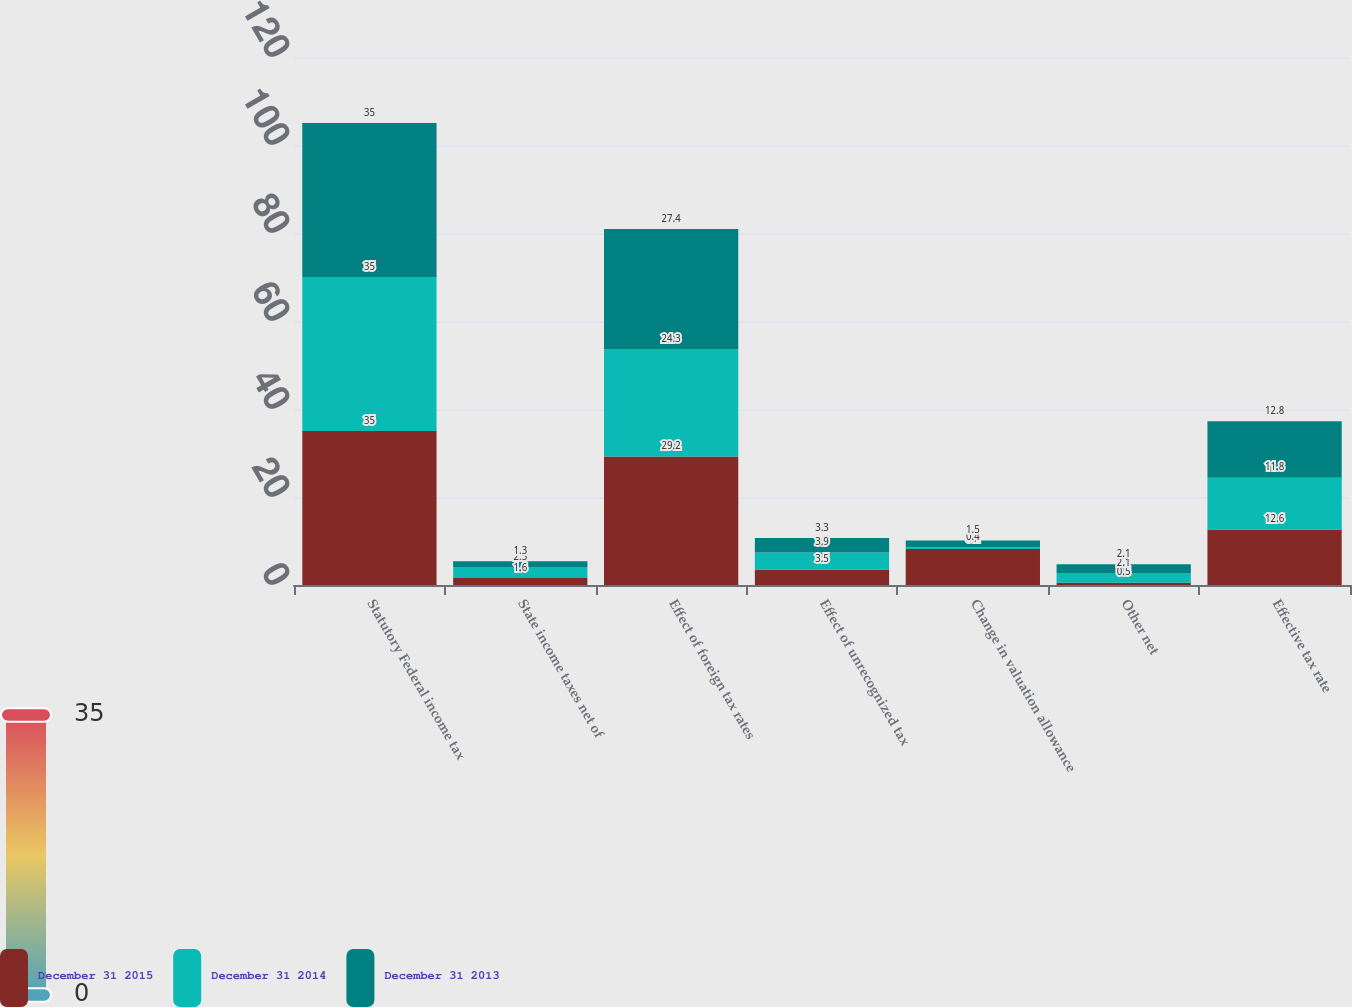Convert chart to OTSL. <chart><loc_0><loc_0><loc_500><loc_500><stacked_bar_chart><ecel><fcel>Statutory Federal income tax<fcel>State income taxes net of<fcel>Effect of foreign tax rates<fcel>Effect of unrecognized tax<fcel>Change in valuation allowance<fcel>Other net<fcel>Effective tax rate<nl><fcel>December 31 2015<fcel>35<fcel>1.6<fcel>29.2<fcel>3.5<fcel>8.2<fcel>0.5<fcel>12.6<nl><fcel>December 31 2014<fcel>35<fcel>2.5<fcel>24.3<fcel>3.9<fcel>0.4<fcel>2.1<fcel>11.8<nl><fcel>December 31 2013<fcel>35<fcel>1.3<fcel>27.4<fcel>3.3<fcel>1.5<fcel>2.1<fcel>12.8<nl></chart> 